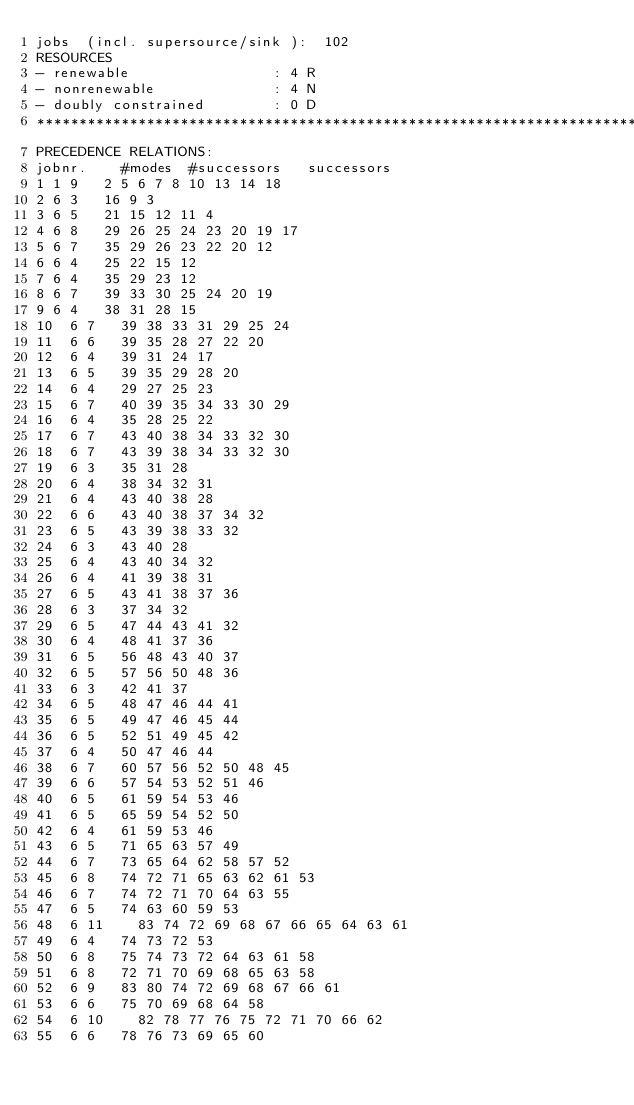<code> <loc_0><loc_0><loc_500><loc_500><_ObjectiveC_>jobs  (incl. supersource/sink ):	102
RESOURCES
- renewable                 : 4 R
- nonrenewable              : 4 N
- doubly constrained        : 0 D
************************************************************************
PRECEDENCE RELATIONS:
jobnr.    #modes  #successors   successors
1	1	9		2 5 6 7 8 10 13 14 18 
2	6	3		16 9 3 
3	6	5		21 15 12 11 4 
4	6	8		29 26 25 24 23 20 19 17 
5	6	7		35 29 26 23 22 20 12 
6	6	4		25 22 15 12 
7	6	4		35 29 23 12 
8	6	7		39 33 30 25 24 20 19 
9	6	4		38 31 28 15 
10	6	7		39 38 33 31 29 25 24 
11	6	6		39 35 28 27 22 20 
12	6	4		39 31 24 17 
13	6	5		39 35 29 28 20 
14	6	4		29 27 25 23 
15	6	7		40 39 35 34 33 30 29 
16	6	4		35 28 25 22 
17	6	7		43 40 38 34 33 32 30 
18	6	7		43 39 38 34 33 32 30 
19	6	3		35 31 28 
20	6	4		38 34 32 31 
21	6	4		43 40 38 28 
22	6	6		43 40 38 37 34 32 
23	6	5		43 39 38 33 32 
24	6	3		43 40 28 
25	6	4		43 40 34 32 
26	6	4		41 39 38 31 
27	6	5		43 41 38 37 36 
28	6	3		37 34 32 
29	6	5		47 44 43 41 32 
30	6	4		48 41 37 36 
31	6	5		56 48 43 40 37 
32	6	5		57 56 50 48 36 
33	6	3		42 41 37 
34	6	5		48 47 46 44 41 
35	6	5		49 47 46 45 44 
36	6	5		52 51 49 45 42 
37	6	4		50 47 46 44 
38	6	7		60 57 56 52 50 48 45 
39	6	6		57 54 53 52 51 46 
40	6	5		61 59 54 53 46 
41	6	5		65 59 54 52 50 
42	6	4		61 59 53 46 
43	6	5		71 65 63 57 49 
44	6	7		73 65 64 62 58 57 52 
45	6	8		74 72 71 65 63 62 61 53 
46	6	7		74 72 71 70 64 63 55 
47	6	5		74 63 60 59 53 
48	6	11		83 74 72 69 68 67 66 65 64 63 61 
49	6	4		74 73 72 53 
50	6	8		75 74 73 72 64 63 61 58 
51	6	8		72 71 70 69 68 65 63 58 
52	6	9		83 80 74 72 69 68 67 66 61 
53	6	6		75 70 69 68 64 58 
54	6	10		82 78 77 76 75 72 71 70 66 62 
55	6	6		78 76 73 69 65 60 </code> 